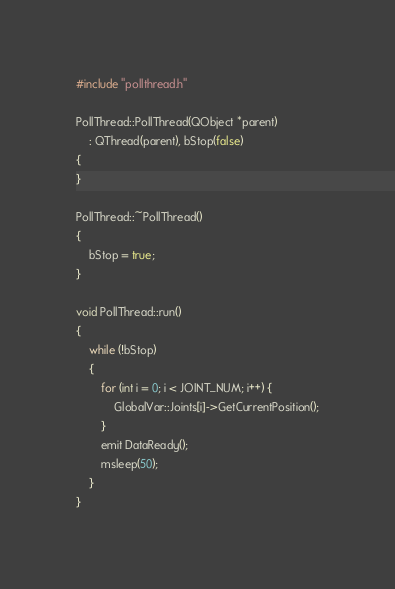<code> <loc_0><loc_0><loc_500><loc_500><_C++_>#include "pollthread.h"

PollThread::PollThread(QObject *parent)
	: QThread(parent), bStop(false)
{
}

PollThread::~PollThread()
{
	bStop = true;
}

void PollThread::run()
{
	while (!bStop)
	{
		for (int i = 0; i < JOINT_NUM; i++) {
			GlobalVar::Joints[i]->GetCurrentPosition();
		}
		emit DataReady();
		msleep(50);
	}
}
</code> 